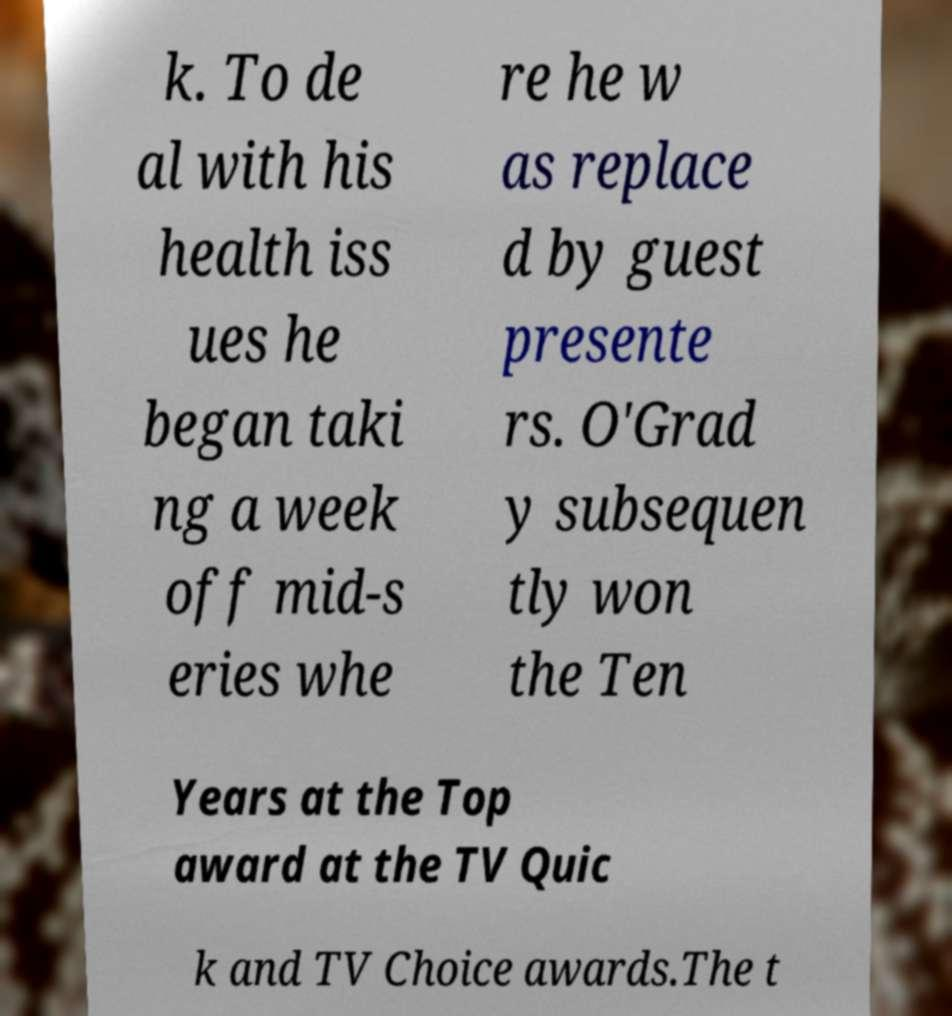For documentation purposes, I need the text within this image transcribed. Could you provide that? k. To de al with his health iss ues he began taki ng a week off mid-s eries whe re he w as replace d by guest presente rs. O'Grad y subsequen tly won the Ten Years at the Top award at the TV Quic k and TV Choice awards.The t 